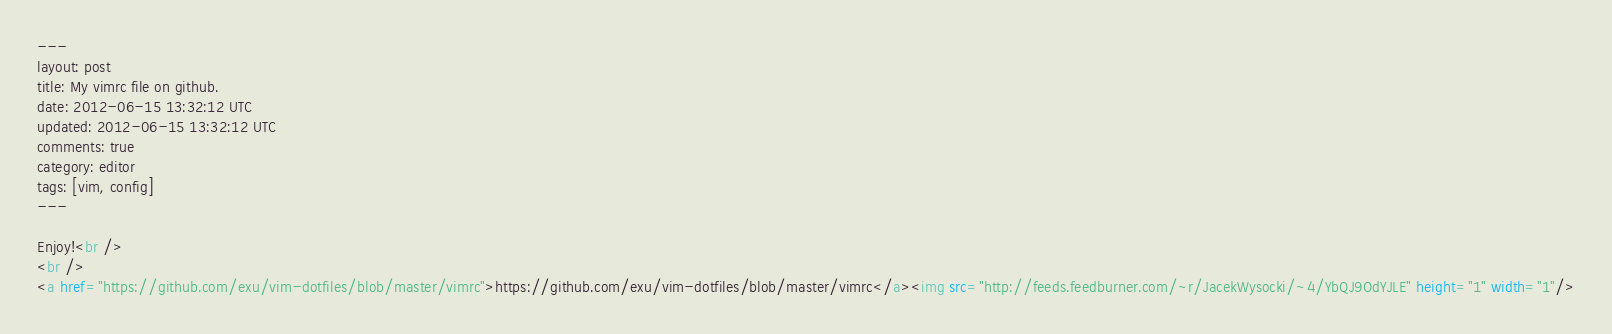<code> <loc_0><loc_0><loc_500><loc_500><_HTML_>---
layout: post
title: My vimrc file on github.
date: 2012-06-15 13:32:12 UTC
updated: 2012-06-15 13:32:12 UTC
comments: true
category: editor
tags: [vim, config]
---

Enjoy!<br />
<br />
<a href="https://github.com/exu/vim-dotfiles/blob/master/vimrc">https://github.com/exu/vim-dotfiles/blob/master/vimrc</a><img src="http://feeds.feedburner.com/~r/JacekWysocki/~4/YbQJ9OdYJLE" height="1" width="1"/>
</code> 